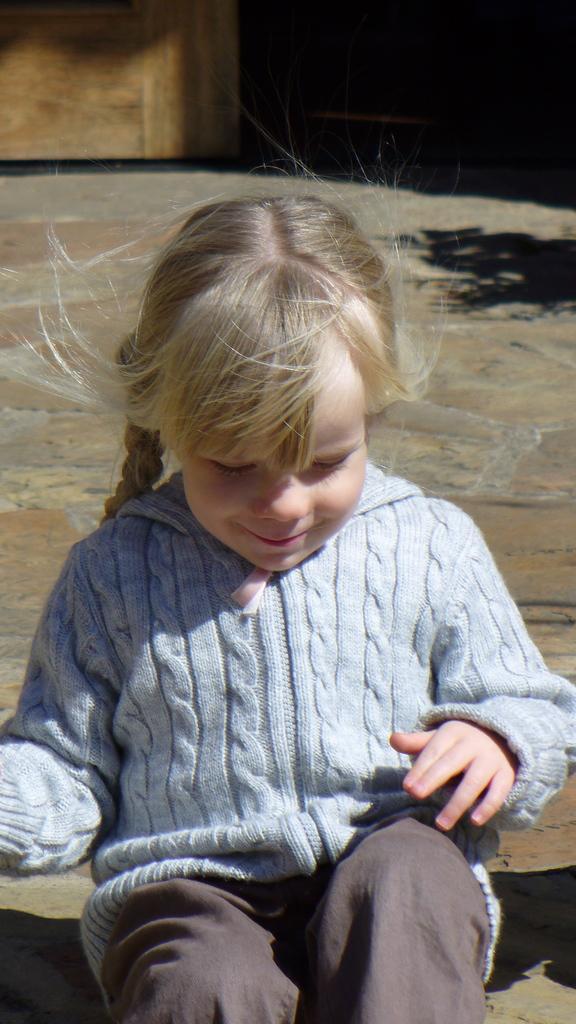Please provide a concise description of this image. A girl is sitting and smiling wearing a blue t shirt and a pant. 